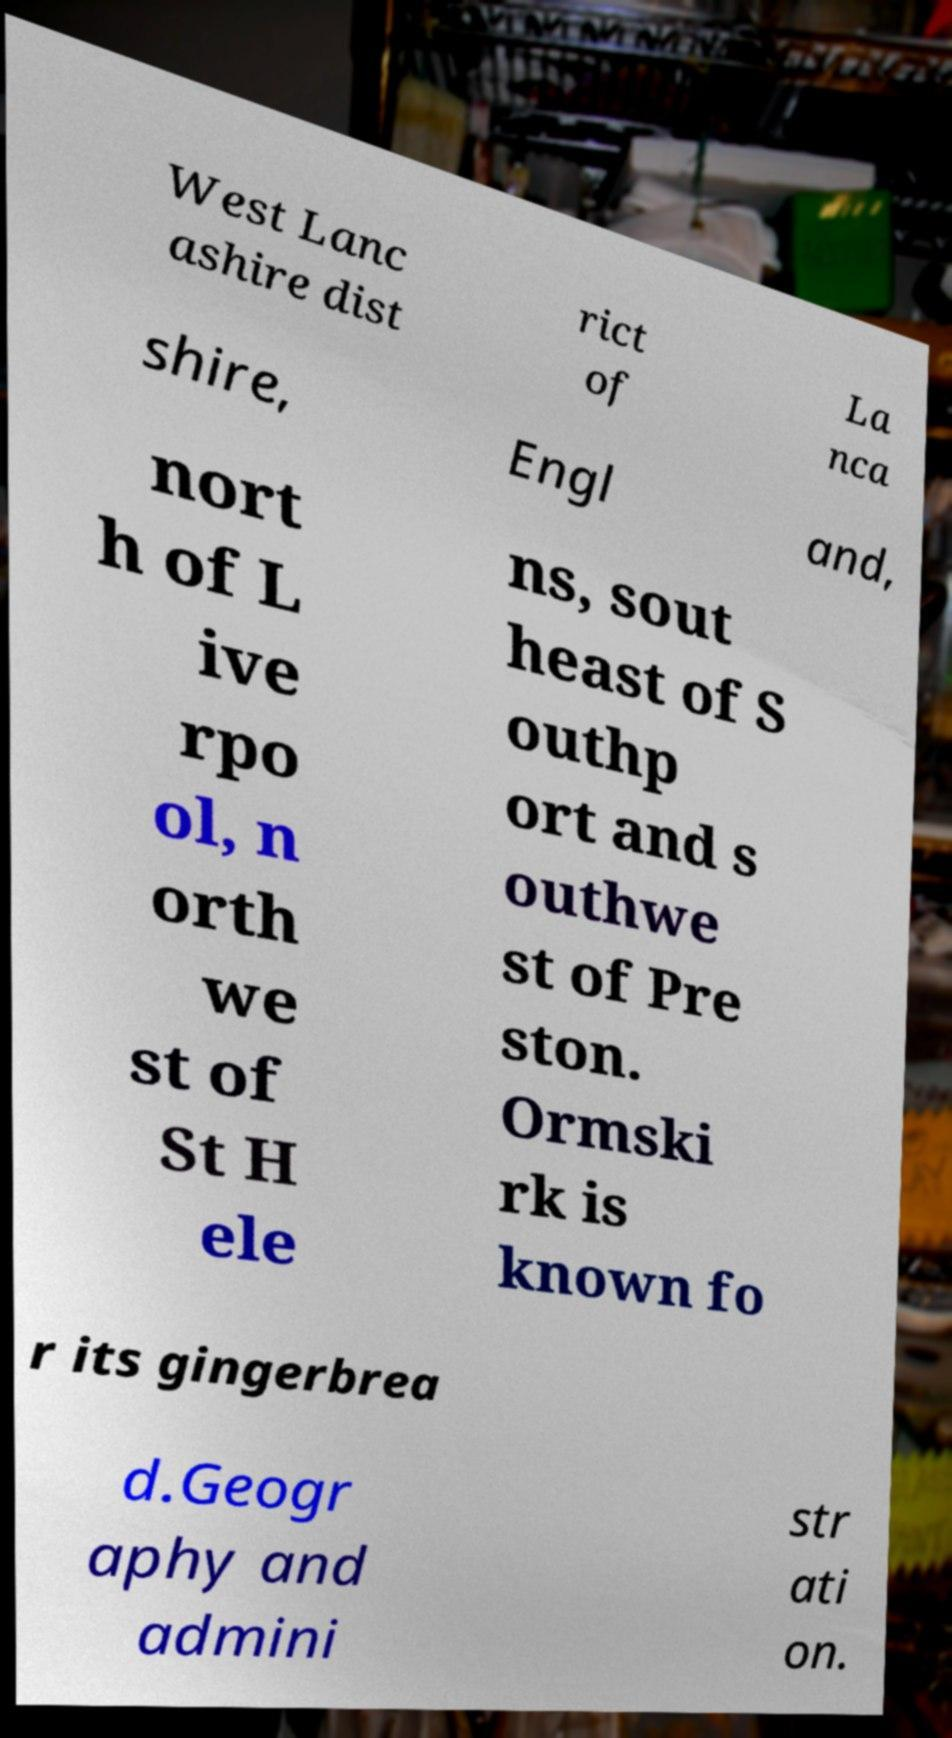For documentation purposes, I need the text within this image transcribed. Could you provide that? West Lanc ashire dist rict of La nca shire, Engl and, nort h of L ive rpo ol, n orth we st of St H ele ns, sout heast of S outhp ort and s outhwe st of Pre ston. Ormski rk is known fo r its gingerbrea d.Geogr aphy and admini str ati on. 